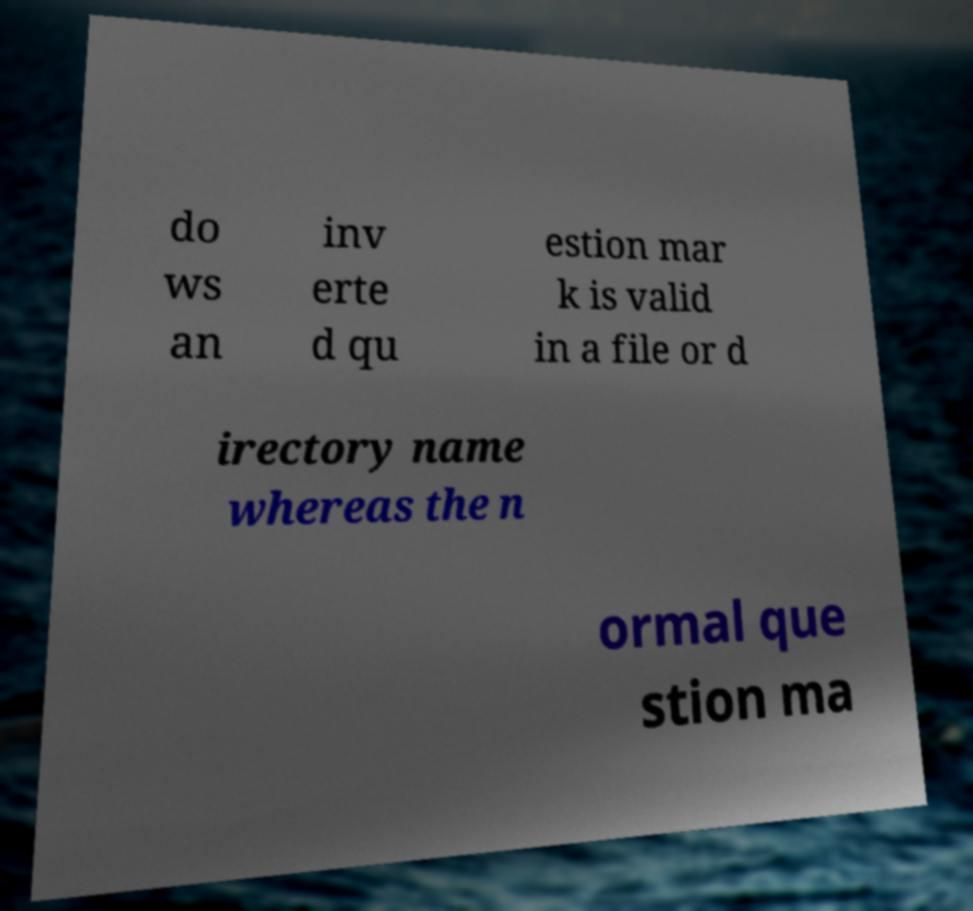I need the written content from this picture converted into text. Can you do that? do ws an inv erte d qu estion mar k is valid in a file or d irectory name whereas the n ormal que stion ma 